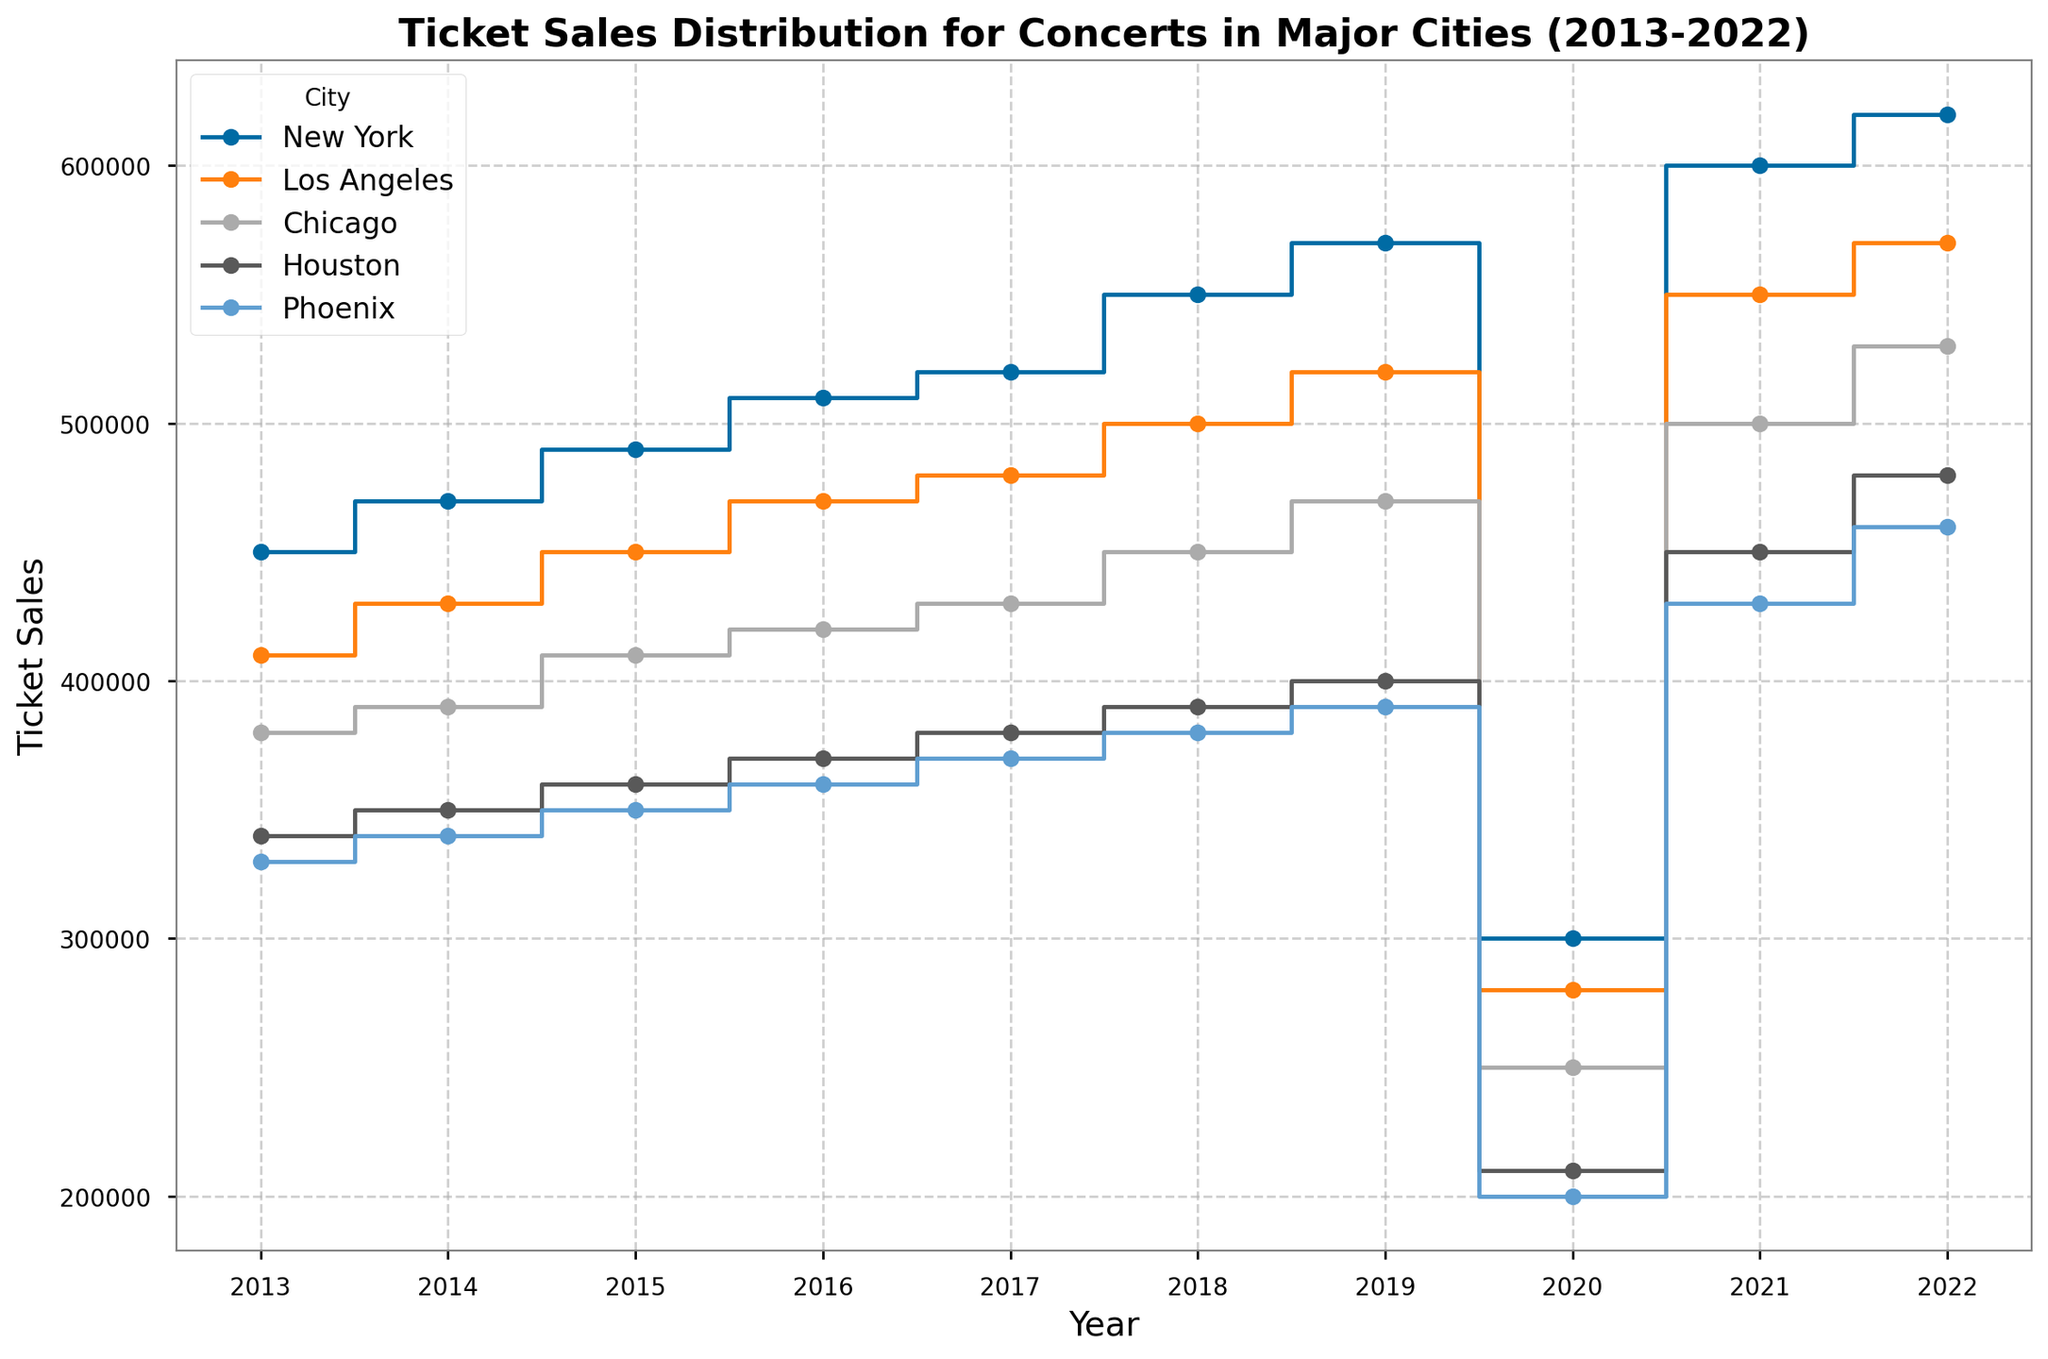What was the total ticket sales in New York across the entire decade? Sum the ticket sales for each year in New York: 450000 (2013) + 470000 (2014) + 490000 (2015) + 510000 (2016) + 520000 (2017) + 550000 (2018) + 570000 (2019) + 300000 (2020) + 600000 (2021) + 620000 (2022). The total is 5080000.
Answer: 5080000 Which city had the greatest increase in ticket sales from 2020 to 2021? Calculate the difference in ticket sales from 2020 to 2021 for each city and compare. New York: 600000 - 300000 = 300000, Los Angeles: 550000 - 280000 = 270000, Chicago: 500000 - 250000 = 250000, Houston: 450000 - 210000 = 240000, Phoenix: 430000 - 200000 = 230000. New York had the greatest increase.
Answer: New York How did the ticket sales in Chicago in 2013 compare to those in 2022? Look at the ticket sales for Chicago in 2013 and 2022 from the graph. 2013: 380000, 2022: 530000.
Answer: 530000 is higher What was the average yearly ticket sales in Los Angeles over the decade? Sum the ticket sales for each year in Los Angeles and divide by the number of years: (410000 + 430000 + 450000 + 470000 + 480000 + 500000 + 520000 + 280000 + 550000 + 570000) / 10. Total is 4660000, so the average is 4660000 / 10 = 466000.
Answer: 466000 Which year saw the lowest ticket sales across all cities? Find the year from the graph that shows the lowest ticket sales across all cities. In 2020, all cities have significantly lower ticket sales compared to other years.
Answer: 2020 By what percentage did ticket sales in Phoenix increase from 2020 to 2022? Calculate the percentage increase in ticket sales from 2020 to 2022 for Phoenix: ((460000 - 200000) / 200000) * 100 = 130%.
Answer: 130% Which city had consistent growth in ticket sales without any drop from 2013 to 2022? Observe the trend lines for each city on the graph. New York, Los Angeles, and Chicago show consistent growth without any drop except for the dip in 2020 due to the pandemic.
Answer: New York, Los Angeles, and Chicago What was the percentage decrease in ticket sales in Houston from 2019 to 2020? Calculate the percentage decrease in ticket sales from 2019 to 2020 for Houston: ((400000 - 210000) / 400000) * 100 = 47.5%.
Answer: 47.5% Did any city return to pre-2020 sales levels by 2021? Compare the 2021 ticket sales to the values before 2020. All cities reached or exceeded pre-2020 sales levels by 2021.
Answer: Yes Among the cities, which had the smallest variation in ticket sales over the decade? Examine the variability in ticket sales for each city. Phoenix shows the smallest variation in ticket sales over the decade.
Answer: Phoenix 